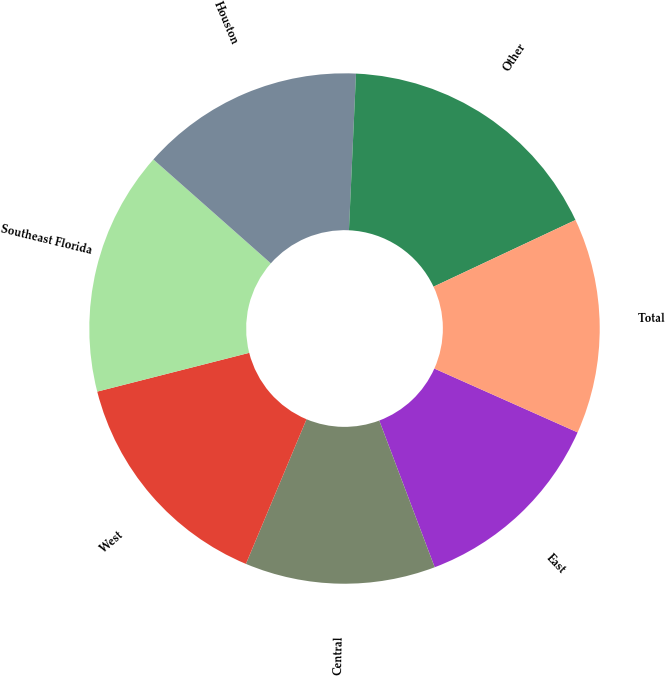<chart> <loc_0><loc_0><loc_500><loc_500><pie_chart><fcel>East<fcel>Central<fcel>West<fcel>Southeast Florida<fcel>Houston<fcel>Other<fcel>Total<nl><fcel>12.58%<fcel>12.06%<fcel>14.71%<fcel>15.5%<fcel>14.19%<fcel>17.29%<fcel>13.66%<nl></chart> 